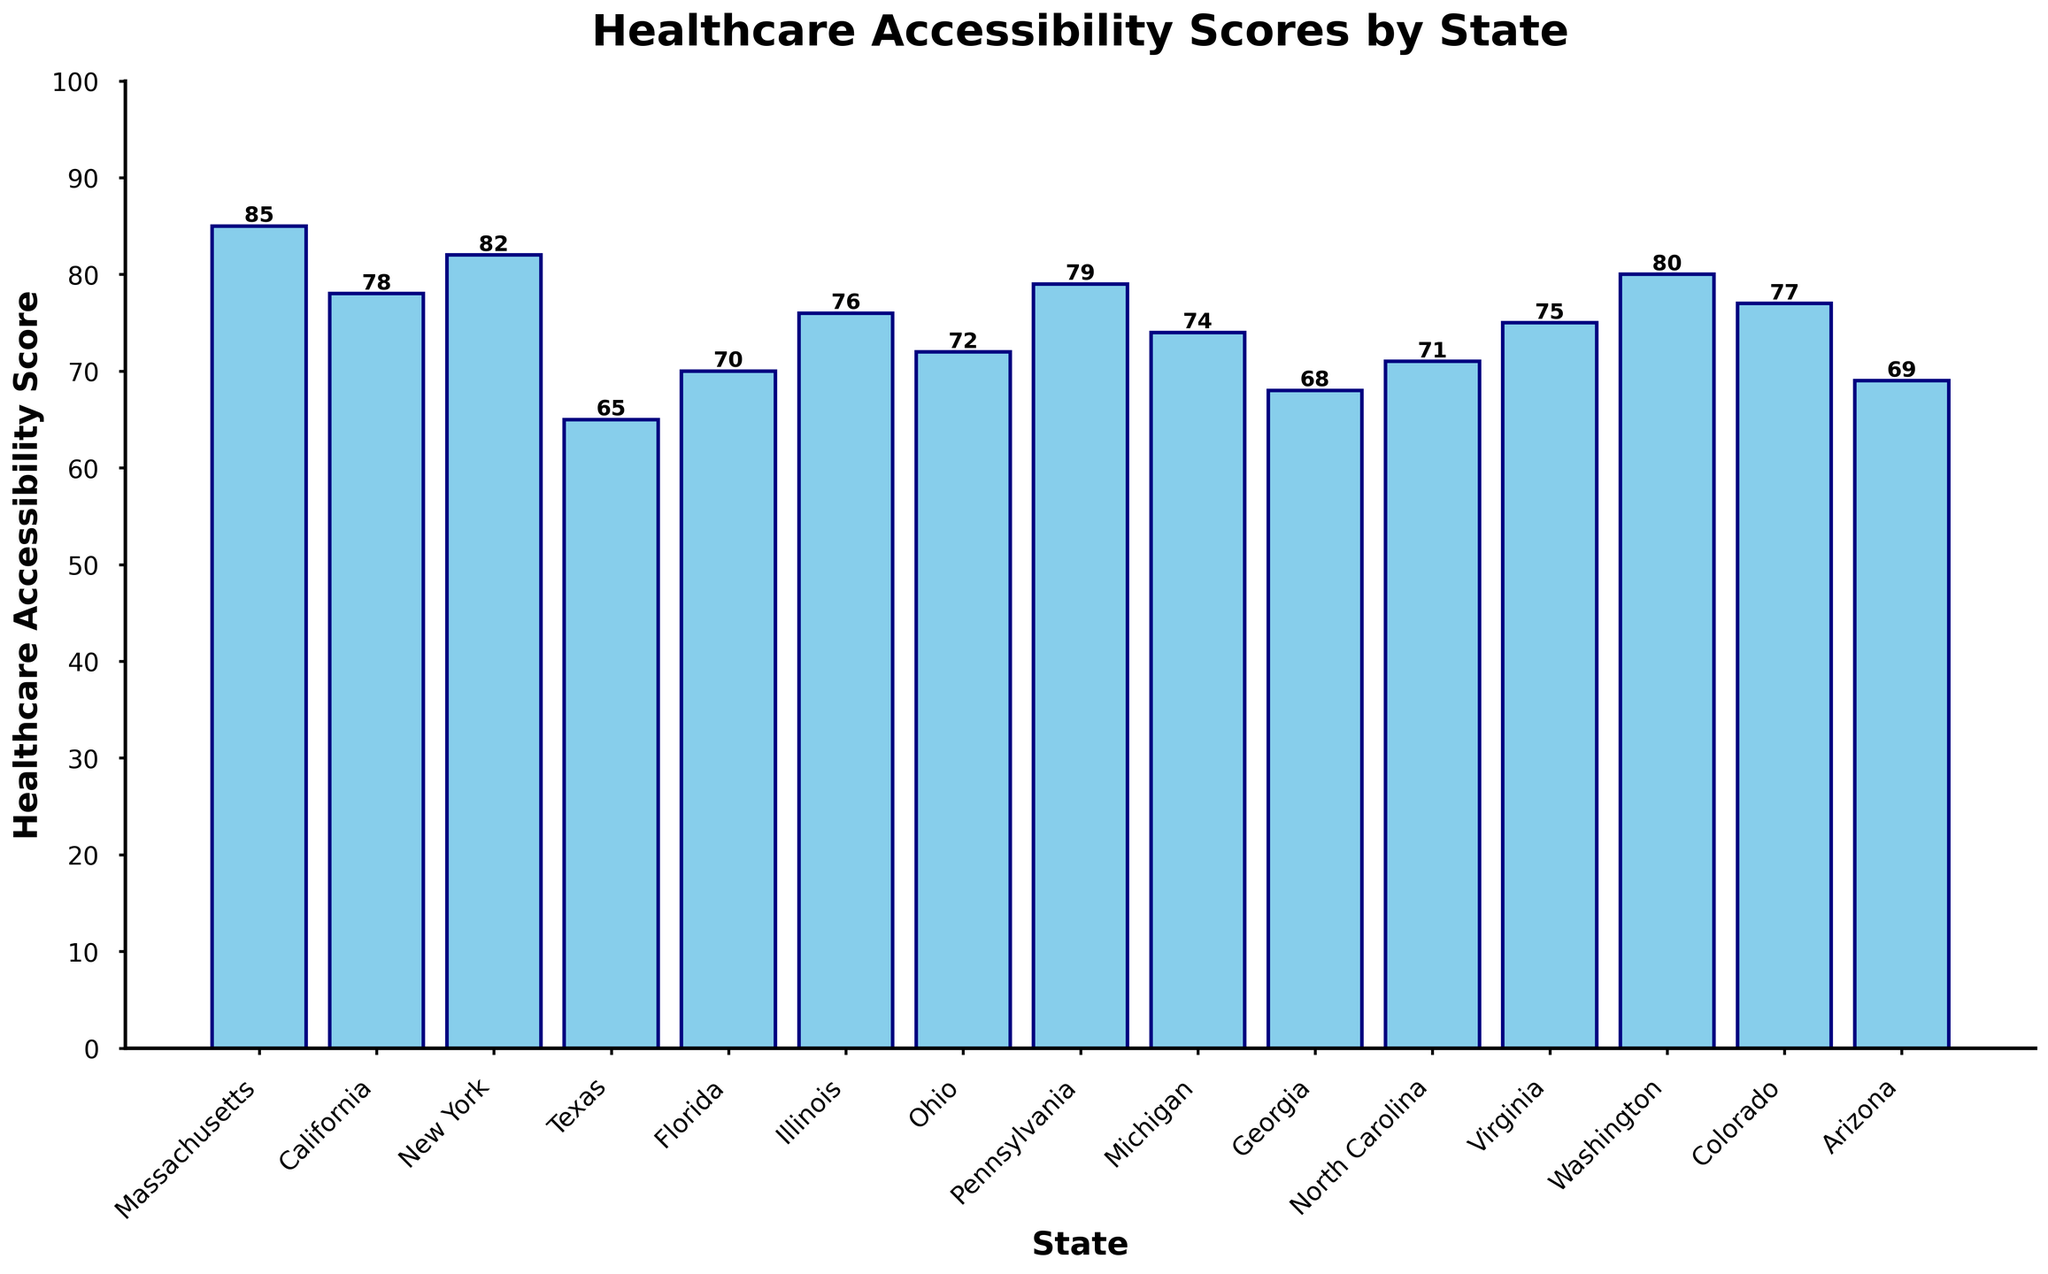Which state has the highest healthcare accessibility score? The highest bar represents the state with the highest score. Massachusetts has the tallest bar with a score of 85.
Answer: Massachusetts Which state has the lowest healthcare accessibility score? The lowest bar represents the state with the lowest score. Texas has the shortest bar with a score of 65.
Answer: Texas What is the average healthcare accessibility score of all the states? Sum all the scores and divide by the number of states: (85 + 78 + 82 + 65 + 70 + 76 + 72 + 79 + 74 + 68 + 71 + 75 + 80 + 77 + 69) / 15 = 76
Answer: 76 How many states have a healthcare accessibility score above 80? Count the bars with heights above the 80 mark. Five states (Massachusetts, New York, Pennsylvania, Washington, and New York).
Answer: 5 Which states have healthcare accessibility scores between 70 and 80? Identify bars with heights in the range 70 to 80. California, Illinois, Ohio, Michigan, North Carolina, Virginia, Colorado, and Florida fall into this range.
Answer: California, Illinois, Ohio, Michigan, North Carolina, Virginia, Colorado, Florida Which state has an accessibility score closest to the national average? The average score is 76; find the state with a score closest to 76. Colorado has a score of 77, which is closest to 76.
Answer: Colorado What is the difference in healthcare accessibility scores between Massachusetts and Texas? Subtract Texas' score from Massachusetts' score: 85 - 65 = 20.
Answer: 20 Which states have equal healthcare accessibility scores? Compare the heights of the bars to find any that are equal. No two states have exactly equal scores.
Answer: No states Rank the healthcare accessibility scores from highest to lowest. List the scores in descending order: Massachusetts (85), New York (82), Pennsylvania (79), Washington (80), California (78), Colorado (77), Illinois (76), Virginia (75), Michigan (74), Ohio (72), North Carolina (71), Florida (70), Arizona (69), Georgia (68), Texas (65).
Answer: Massachusetts, New York, Pennsylvania, Washington, California, Colorado, Illinois, Virginia, Michigan, Ohio, North Carolina, Florida, Arizona, Georgia, Texas How many states have healthcare accessibility scores below the median score? First find the median score by arranging in ascending order: 65, 68, 69, 70, 71, 72, 74, 75, 76, 77, 78, 79, 80, 82, 85 (median is 75). Count the bars below 75: 7 states (Texas, Georgia, Arizona, Florida, North Carolina, Ohio, Michigan).
Answer: 7 